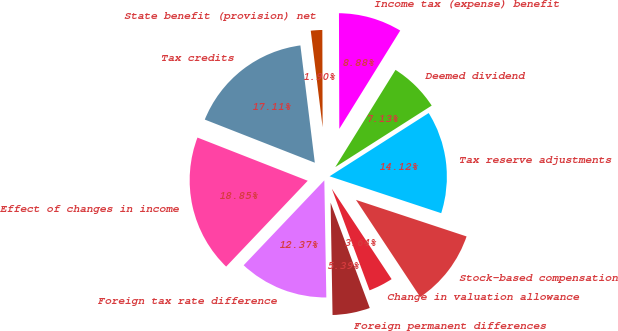<chart> <loc_0><loc_0><loc_500><loc_500><pie_chart><fcel>Income tax (expense) benefit<fcel>State benefit (provision) net<fcel>Tax credits<fcel>Effect of changes in income<fcel>Foreign tax rate difference<fcel>Foreign permanent differences<fcel>Change in valuation allowance<fcel>Stock-based compensation<fcel>Tax reserve adjustments<fcel>Deemed dividend<nl><fcel>8.88%<fcel>1.9%<fcel>17.11%<fcel>18.85%<fcel>12.37%<fcel>5.39%<fcel>3.64%<fcel>10.62%<fcel>14.12%<fcel>7.13%<nl></chart> 